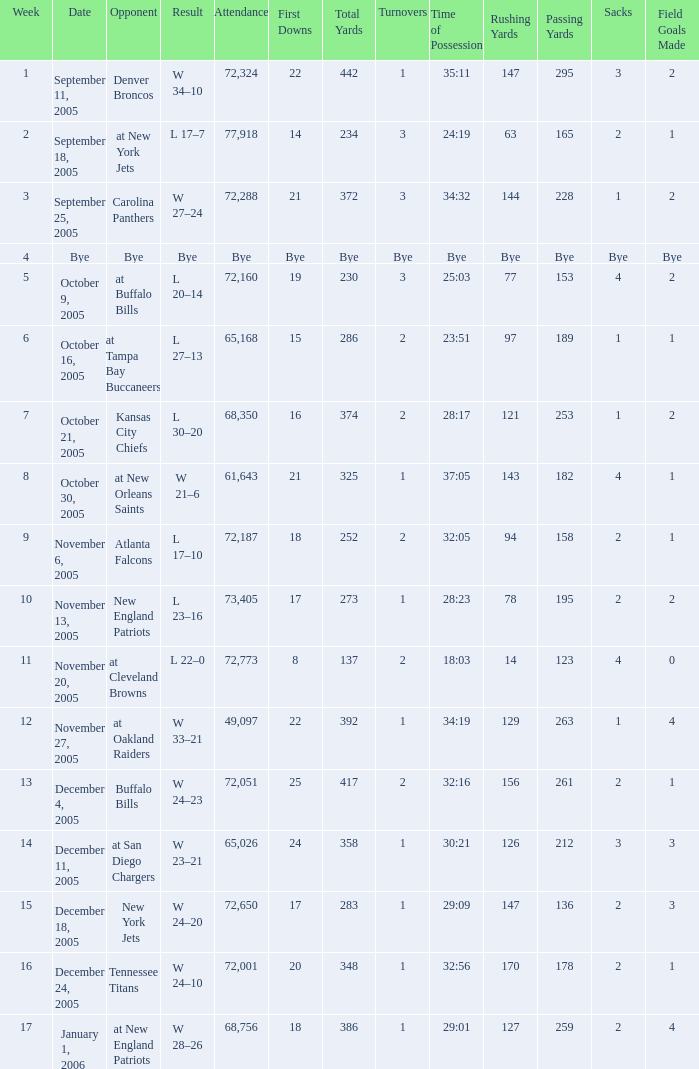On what Date was the Attendance 73,405? November 13, 2005. 